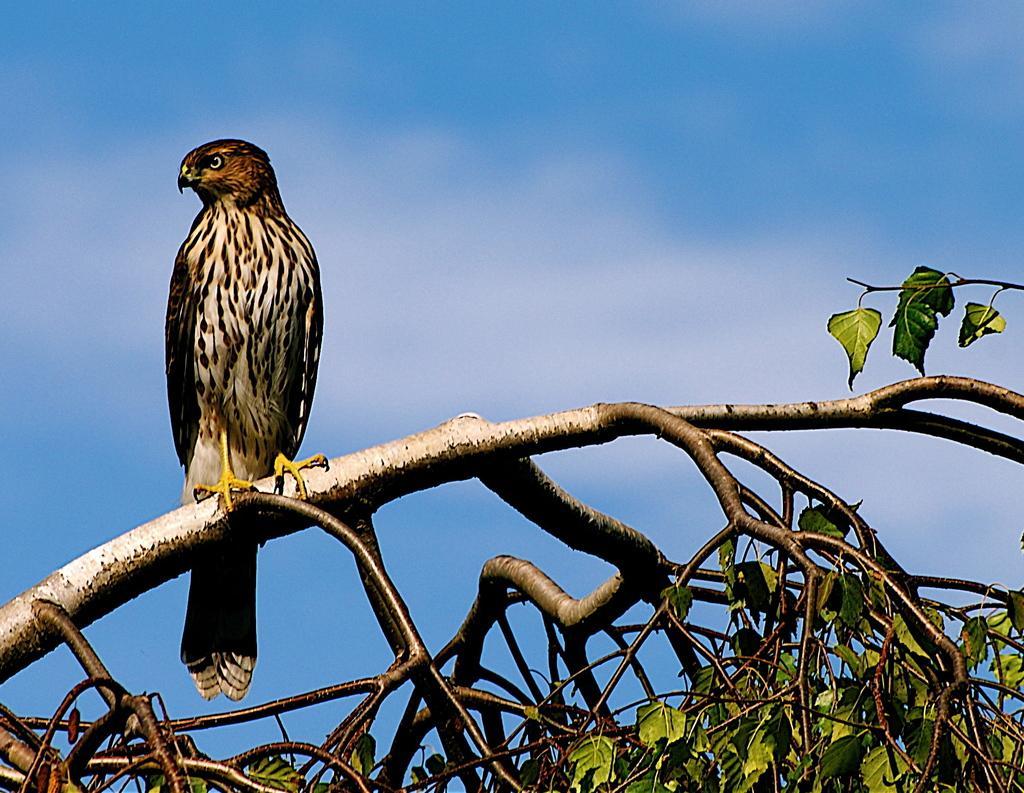In one or two sentences, can you explain what this image depicts? In this image I can see image a bird in brown and black color standing on the branch. I can also see trees in green color, background I can sky in blue color. 